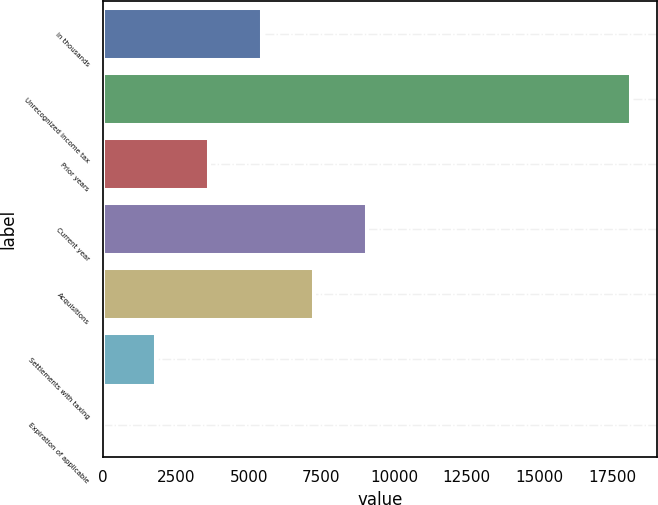Convert chart. <chart><loc_0><loc_0><loc_500><loc_500><bar_chart><fcel>in thousands<fcel>Unrecognized income tax<fcel>Prior years<fcel>Current year<fcel>Acquisitions<fcel>Settlements with taxing<fcel>Expiration of applicable<nl><fcel>5442.56<fcel>18131<fcel>3629.93<fcel>9067.82<fcel>7255.19<fcel>1817.3<fcel>4.67<nl></chart> 